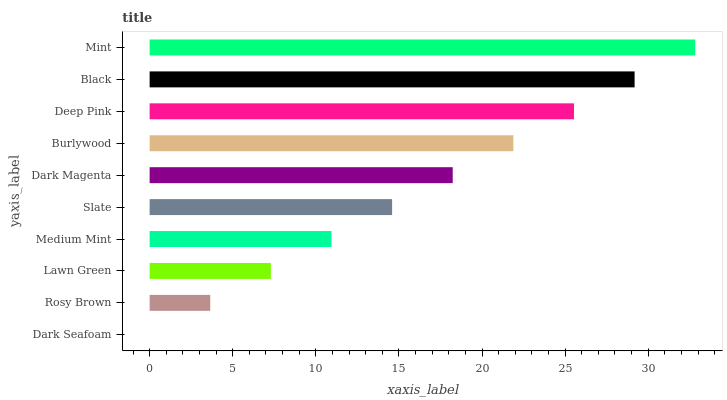Is Dark Seafoam the minimum?
Answer yes or no. Yes. Is Mint the maximum?
Answer yes or no. Yes. Is Rosy Brown the minimum?
Answer yes or no. No. Is Rosy Brown the maximum?
Answer yes or no. No. Is Rosy Brown greater than Dark Seafoam?
Answer yes or no. Yes. Is Dark Seafoam less than Rosy Brown?
Answer yes or no. Yes. Is Dark Seafoam greater than Rosy Brown?
Answer yes or no. No. Is Rosy Brown less than Dark Seafoam?
Answer yes or no. No. Is Dark Magenta the high median?
Answer yes or no. Yes. Is Slate the low median?
Answer yes or no. Yes. Is Medium Mint the high median?
Answer yes or no. No. Is Dark Magenta the low median?
Answer yes or no. No. 